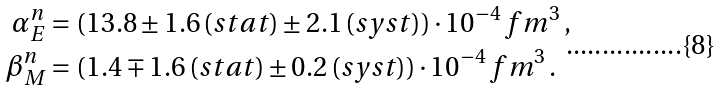Convert formula to latex. <formula><loc_0><loc_0><loc_500><loc_500>\alpha _ { E } ^ { n } & = ( 1 3 . 8 \pm 1 . 6 \, ( s t a t ) \pm 2 . 1 \, ( s y s t ) ) \cdot 1 0 ^ { - 4 } \, f m ^ { 3 } \, , \\ \beta _ { M } ^ { n } & = ( 1 . 4 \mp 1 . 6 \, ( s t a t ) \pm 0 . 2 \, ( s y s t ) ) \cdot 1 0 ^ { - 4 } \, f m ^ { 3 } \, .</formula> 